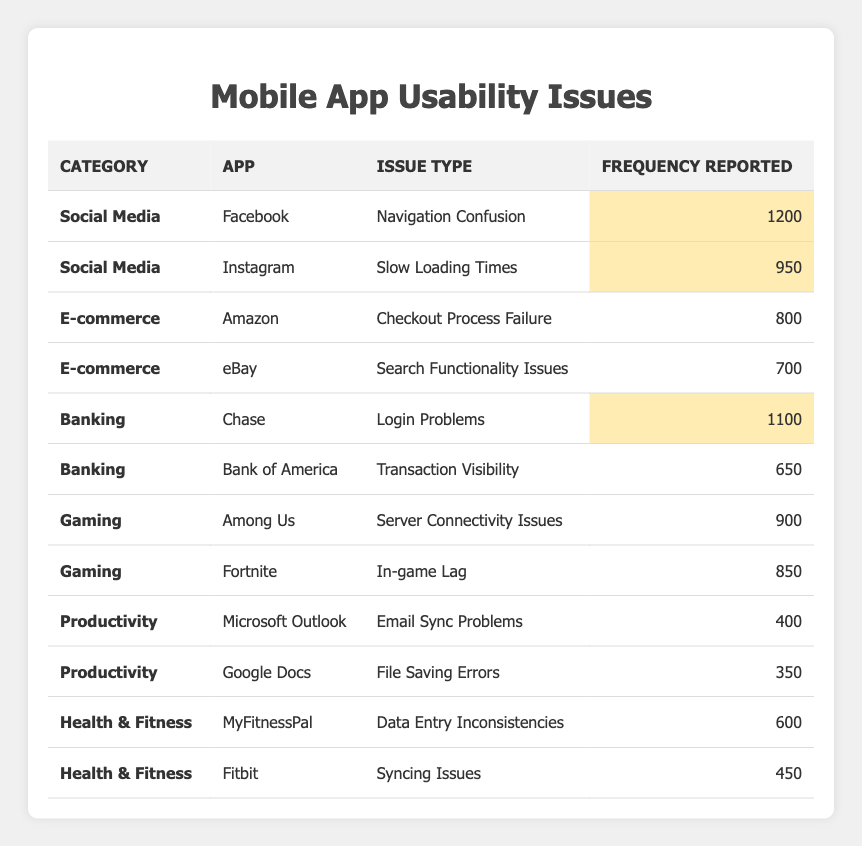What is the most reported usability issue in the social media category? The most reported issue in the social media category is "Navigation Confusion" from the Facebook app, with 1200 reports.
Answer: 1200 Which e-commerce app has the highest frequency of reported usability issues? Amazon has the highest frequency of reported usability issues in the e-commerce category, with 800 reports for "Checkout Process Failure."
Answer: Amazon What is the frequency of login problems reported for banking apps? The frequency of login problems reported for Chase is 1100, while Bank of America has 650 reports for "Transaction Visibility," but there are no reports for "login problems" at Bank of America, so it's 1100 from Chase.
Answer: 1100 Which gaming app has the least reported usability issues? The gaming app with the least reported usability issues is "Fortnite" with 850 reports for "In-game Lag," as compared to 900 reports from "Among Us."
Answer: Fortnite What is the average frequency of usability issues reported in the Productivity category? The total frequency for the Productivity category is 400 (Microsoft Outlook) + 350 (Google Docs) = 750. There are 2 apps in this category, so the average frequency is 750 / 2 = 375.
Answer: 375 Is there any health & fitness app with more than 600 reported issues? Yes, MyFitnessPal has 600 reports for "Data Entry Inconsistencies," which is equal to 600, but none exceed that number.
Answer: Yes What is the total frequency of reported issues across all categories for the banking apps? The total frequency for banking apps includes 1100 (Chase, Login Problems) + 650 (Bank of America, Transaction Visibility) = 1750.
Answer: 1750 Which app in the health & fitness category has the highest frequency of reports? MyFitnessPal has a frequency of 600 reports, which is higher than Fitbit's 450 reports for "Syncing Issues."
Answer: MyFitnessPal How many categories have reported usability issues above 900? There are four instances above 900: Facebook (1200), Instagram (950), Chase (1100), and Among Us (900).
Answer: 4 What is the frequency difference between the highest and lowest reported issues in the Social Media category? The highest reported is 1200 (Facebook) and the lowest is 950 (Instagram). Therefore, the difference is 1200 - 950 = 250.
Answer: 250 